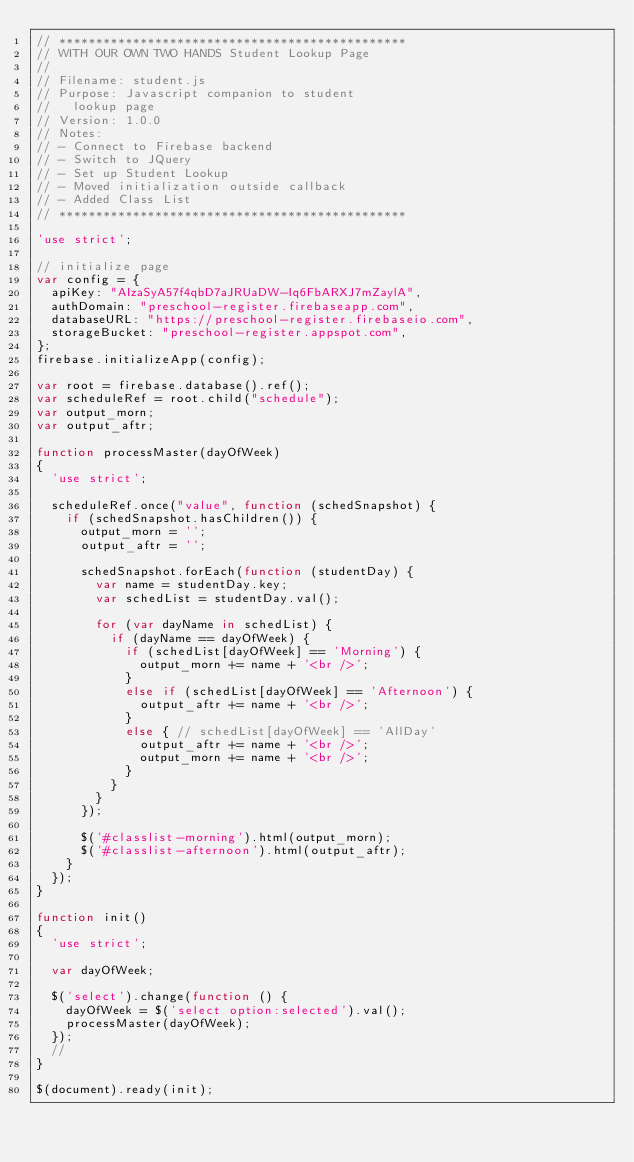<code> <loc_0><loc_0><loc_500><loc_500><_JavaScript_>// ***********************************************
// WITH OUR OWN TWO HANDS Student Lookup Page
// 
// Filename: student.js
// Purpose: Javascript companion to student
//   lookup page 
// Version: 1.0.0
// Notes: 
// - Connect to Firebase backend
// - Switch to JQuery
// - Set up Student Lookup
// - Moved initialization outside callback
// - Added Class List
// ***********************************************

'use strict';

// initialize page
var config = {
  apiKey: "AIzaSyA57f4qbD7aJRUaDW-Iq6FbARXJ7mZaylA",
  authDomain: "preschool-register.firebaseapp.com",
  databaseURL: "https://preschool-register.firebaseio.com",
  storageBucket: "preschool-register.appspot.com",
};
firebase.initializeApp(config);
	
var root = firebase.database().ref();
var scheduleRef = root.child("schedule");
var output_morn;
var output_aftr;

function processMaster(dayOfWeek)
{
	'use strict';
	
	scheduleRef.once("value", function (schedSnapshot) {
		if (schedSnapshot.hasChildren()) {
			output_morn = '';
			output_aftr = '';
			
			schedSnapshot.forEach(function (studentDay) {
				var name = studentDay.key;
				var schedList = studentDay.val();

				for (var dayName in schedList) {
					if (dayName == dayOfWeek) {
						if (schedList[dayOfWeek] == 'Morning') {
							output_morn += name + '<br />';
						}
						else if (schedList[dayOfWeek] == 'Afternoon') {
							output_aftr += name + '<br />';
						}
						else { // schedList[dayOfWeek] == 'AllDay'
							output_aftr += name + '<br />';
							output_morn += name + '<br />';
						}
					}
				}
			});
			
			$('#classlist-morning').html(output_morn);
			$('#classlist-afternoon').html(output_aftr);
		}
	});
}

function init()
{
	'use strict';
	
	var dayOfWeek;
	
	$('select').change(function () {
		dayOfWeek = $('select option:selected').val(); 
		processMaster(dayOfWeek);
	});
	//
}

$(document).ready(init);</code> 